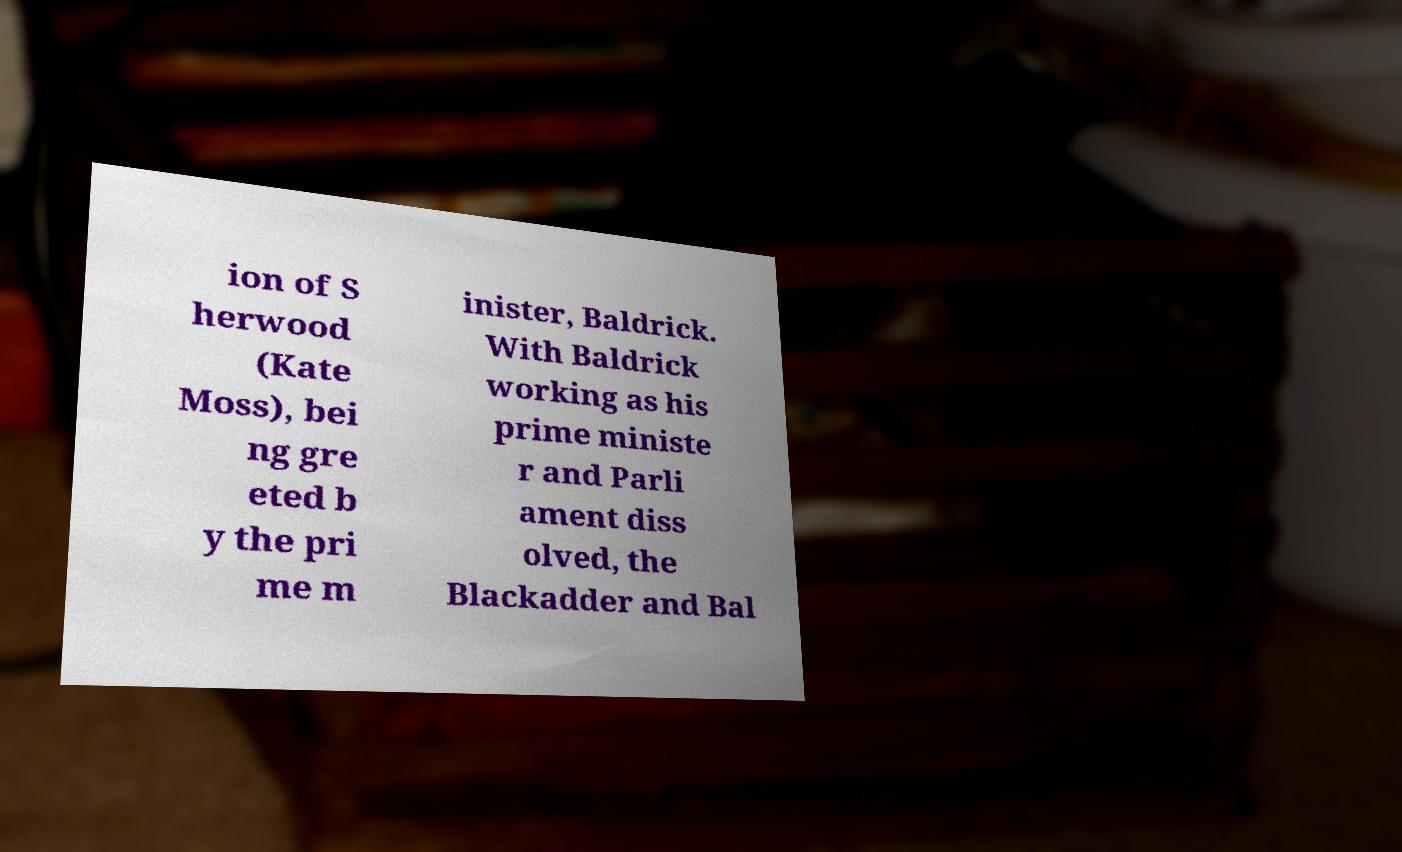For documentation purposes, I need the text within this image transcribed. Could you provide that? ion of S herwood (Kate Moss), bei ng gre eted b y the pri me m inister, Baldrick. With Baldrick working as his prime ministe r and Parli ament diss olved, the Blackadder and Bal 